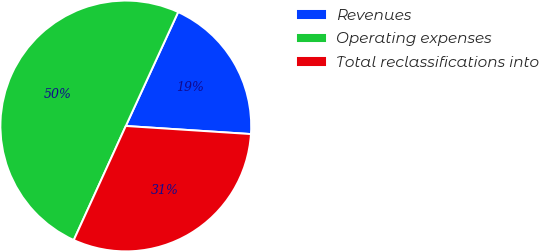<chart> <loc_0><loc_0><loc_500><loc_500><pie_chart><fcel>Revenues<fcel>Operating expenses<fcel>Total reclassifications into<nl><fcel>19.17%<fcel>50.04%<fcel>30.78%<nl></chart> 